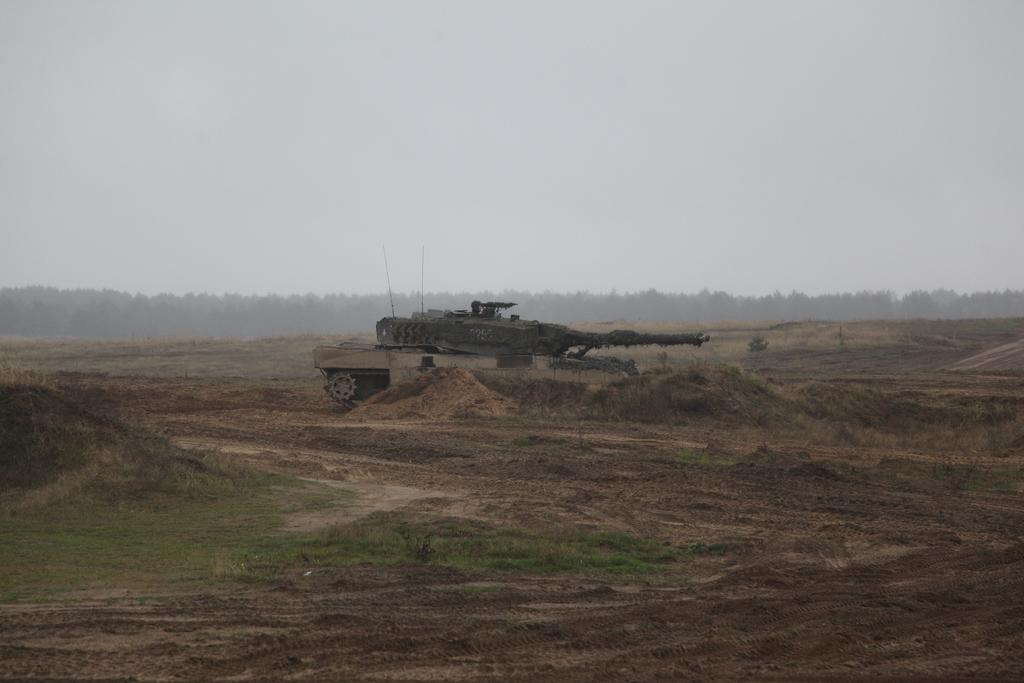What type of vegetation is present in the image? There is grass in the image. What type of vehicle can be seen on the ground in the image? There is a tanker on the ground in the image. What other natural elements are visible in the image? There are trees in the image. What part of the natural environment is visible in the image? The sky is visible in the image. From what perspective was the image taken? The image appears to be taken from ground level. What type of jeans is the harbor wearing in the image? There is no harbor or person wearing jeans present in the image. What time of day is depicted in the image? The provided facts do not give any information about the time of day, so it cannot be determined from the image. 